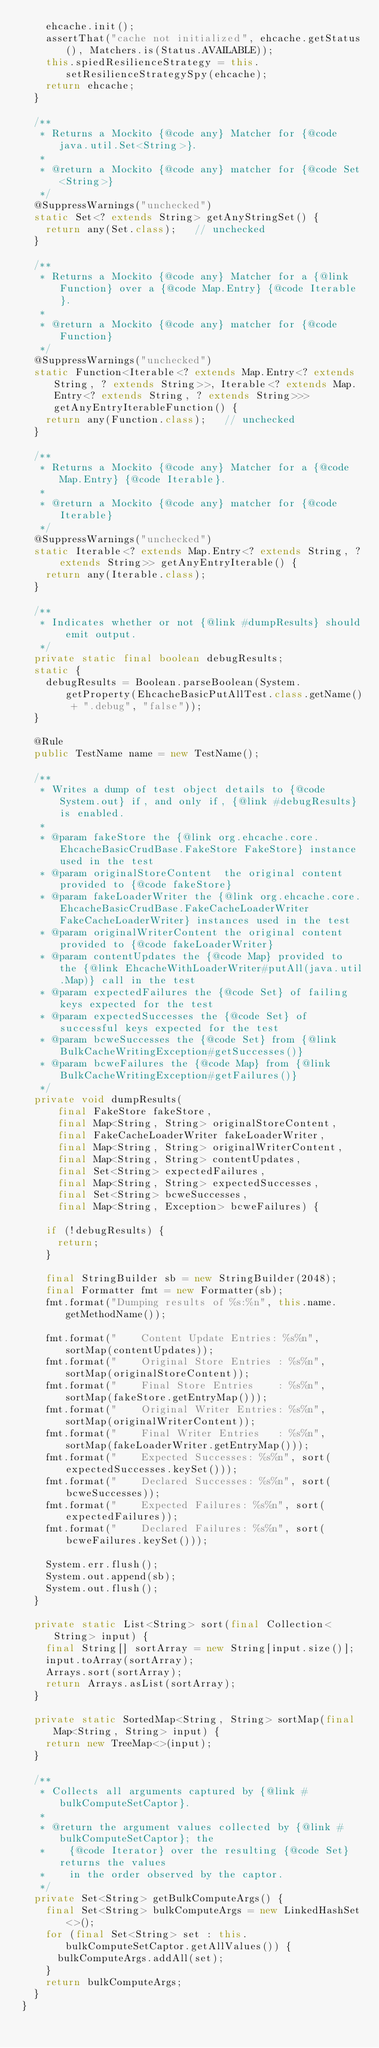<code> <loc_0><loc_0><loc_500><loc_500><_Java_>    ehcache.init();
    assertThat("cache not initialized", ehcache.getStatus(), Matchers.is(Status.AVAILABLE));
    this.spiedResilienceStrategy = this.setResilienceStrategySpy(ehcache);
    return ehcache;
  }

  /**
   * Returns a Mockito {@code any} Matcher for {@code java.util.Set<String>}.
   *
   * @return a Mockito {@code any} matcher for {@code Set<String>}
   */
  @SuppressWarnings("unchecked")
  static Set<? extends String> getAnyStringSet() {
    return any(Set.class);   // unchecked
  }

  /**
   * Returns a Mockito {@code any} Matcher for a {@link Function} over a {@code Map.Entry} {@code Iterable}.
   *
   * @return a Mockito {@code any} matcher for {@code Function}
   */
  @SuppressWarnings("unchecked")
  static Function<Iterable<? extends Map.Entry<? extends String, ? extends String>>, Iterable<? extends Map.Entry<? extends String, ? extends String>>> getAnyEntryIterableFunction() {
    return any(Function.class);   // unchecked
  }

  /**
   * Returns a Mockito {@code any} Matcher for a {@code Map.Entry} {@code Iterable}.
   *
   * @return a Mockito {@code any} matcher for {@code Iterable}
   */
  @SuppressWarnings("unchecked")
  static Iterable<? extends Map.Entry<? extends String, ? extends String>> getAnyEntryIterable() {
    return any(Iterable.class);
  }

  /**
   * Indicates whether or not {@link #dumpResults} should emit output.
   */
  private static final boolean debugResults;
  static {
    debugResults = Boolean.parseBoolean(System.getProperty(EhcacheBasicPutAllTest.class.getName() + ".debug", "false"));
  }

  @Rule
  public TestName name = new TestName();

  /**
   * Writes a dump of test object details to {@code System.out} if, and only if, {@link #debugResults} is enabled.
   *
   * @param fakeStore the {@link org.ehcache.core.EhcacheBasicCrudBase.FakeStore FakeStore} instance used in the test
   * @param originalStoreContent  the original content provided to {@code fakeStore}
   * @param fakeLoaderWriter the {@link org.ehcache.core.EhcacheBasicCrudBase.FakeCacheLoaderWriter FakeCacheLoaderWriter} instances used in the test
   * @param originalWriterContent the original content provided to {@code fakeLoaderWriter}
   * @param contentUpdates the {@code Map} provided to the {@link EhcacheWithLoaderWriter#putAll(java.util.Map)} call in the test
   * @param expectedFailures the {@code Set} of failing keys expected for the test
   * @param expectedSuccesses the {@code Set} of successful keys expected for the test
   * @param bcweSuccesses the {@code Set} from {@link BulkCacheWritingException#getSuccesses()}
   * @param bcweFailures the {@code Map} from {@link BulkCacheWritingException#getFailures()}
   */
  private void dumpResults(
      final FakeStore fakeStore,
      final Map<String, String> originalStoreContent,
      final FakeCacheLoaderWriter fakeLoaderWriter,
      final Map<String, String> originalWriterContent,
      final Map<String, String> contentUpdates,
      final Set<String> expectedFailures,
      final Map<String, String> expectedSuccesses,
      final Set<String> bcweSuccesses,
      final Map<String, Exception> bcweFailures) {

    if (!debugResults) {
      return;
    }

    final StringBuilder sb = new StringBuilder(2048);
    final Formatter fmt = new Formatter(sb);
    fmt.format("Dumping results of %s:%n", this.name.getMethodName());

    fmt.format("    Content Update Entries: %s%n", sortMap(contentUpdates));
    fmt.format("    Original Store Entries : %s%n", sortMap(originalStoreContent));
    fmt.format("    Final Store Entries    : %s%n", sortMap(fakeStore.getEntryMap()));
    fmt.format("    Original Writer Entries: %s%n", sortMap(originalWriterContent));
    fmt.format("    Final Writer Entries   : %s%n", sortMap(fakeLoaderWriter.getEntryMap()));
    fmt.format("    Expected Successes: %s%n", sort(expectedSuccesses.keySet()));
    fmt.format("    Declared Successes: %s%n", sort(bcweSuccesses));
    fmt.format("    Expected Failures: %s%n", sort(expectedFailures));
    fmt.format("    Declared Failures: %s%n", sort(bcweFailures.keySet()));

    System.err.flush();
    System.out.append(sb);
    System.out.flush();
  }

  private static List<String> sort(final Collection<String> input) {
    final String[] sortArray = new String[input.size()];
    input.toArray(sortArray);
    Arrays.sort(sortArray);
    return Arrays.asList(sortArray);
  }

  private static SortedMap<String, String> sortMap(final Map<String, String> input) {
    return new TreeMap<>(input);
  }

  /**
   * Collects all arguments captured by {@link #bulkComputeSetCaptor}.
   *
   * @return the argument values collected by {@link #bulkComputeSetCaptor}; the
   *    {@code Iterator} over the resulting {@code Set} returns the values
   *    in the order observed by the captor.
   */
  private Set<String> getBulkComputeArgs() {
    final Set<String> bulkComputeArgs = new LinkedHashSet<>();
    for (final Set<String> set : this.bulkComputeSetCaptor.getAllValues()) {
      bulkComputeArgs.addAll(set);
    }
    return bulkComputeArgs;
  }
}
</code> 